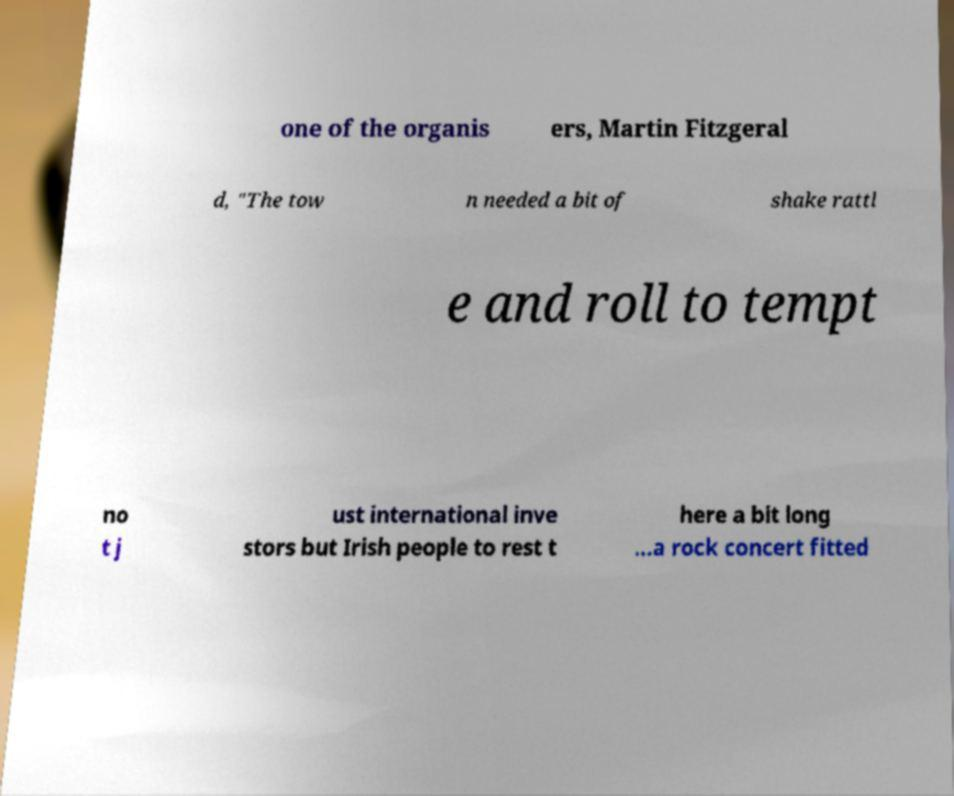What messages or text are displayed in this image? I need them in a readable, typed format. one of the organis ers, Martin Fitzgeral d, "The tow n needed a bit of shake rattl e and roll to tempt no t j ust international inve stors but Irish people to rest t here a bit long ...a rock concert fitted 